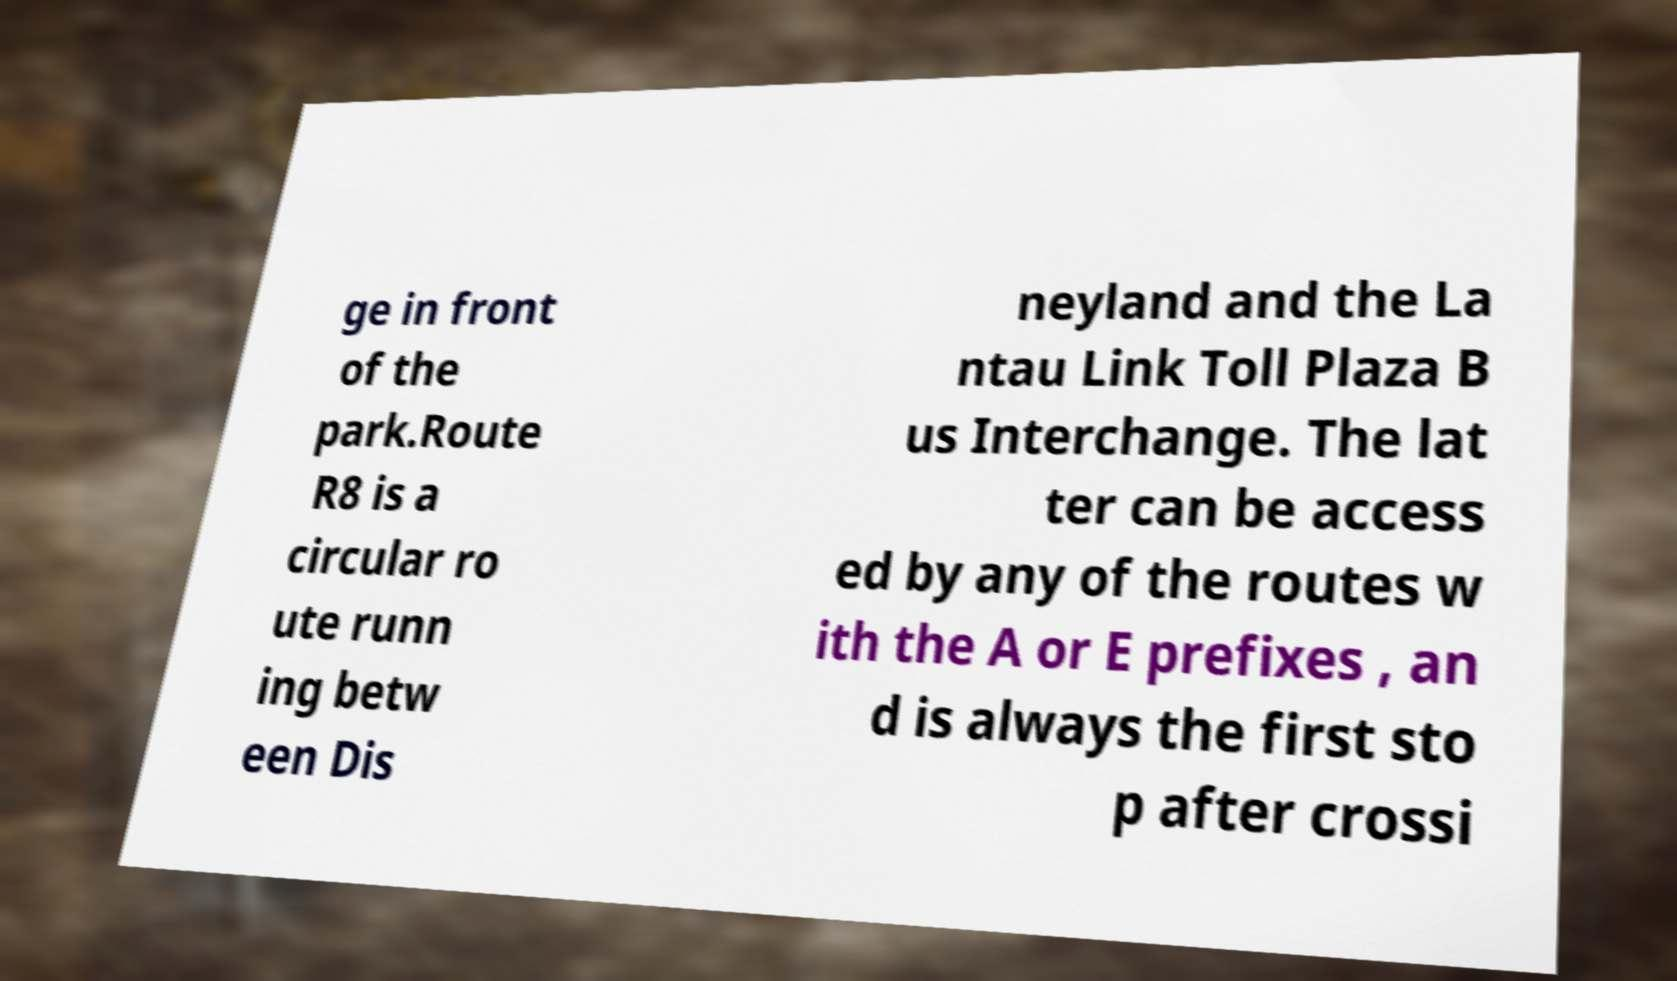There's text embedded in this image that I need extracted. Can you transcribe it verbatim? ge in front of the park.Route R8 is a circular ro ute runn ing betw een Dis neyland and the La ntau Link Toll Plaza B us Interchange. The lat ter can be access ed by any of the routes w ith the A or E prefixes , an d is always the first sto p after crossi 